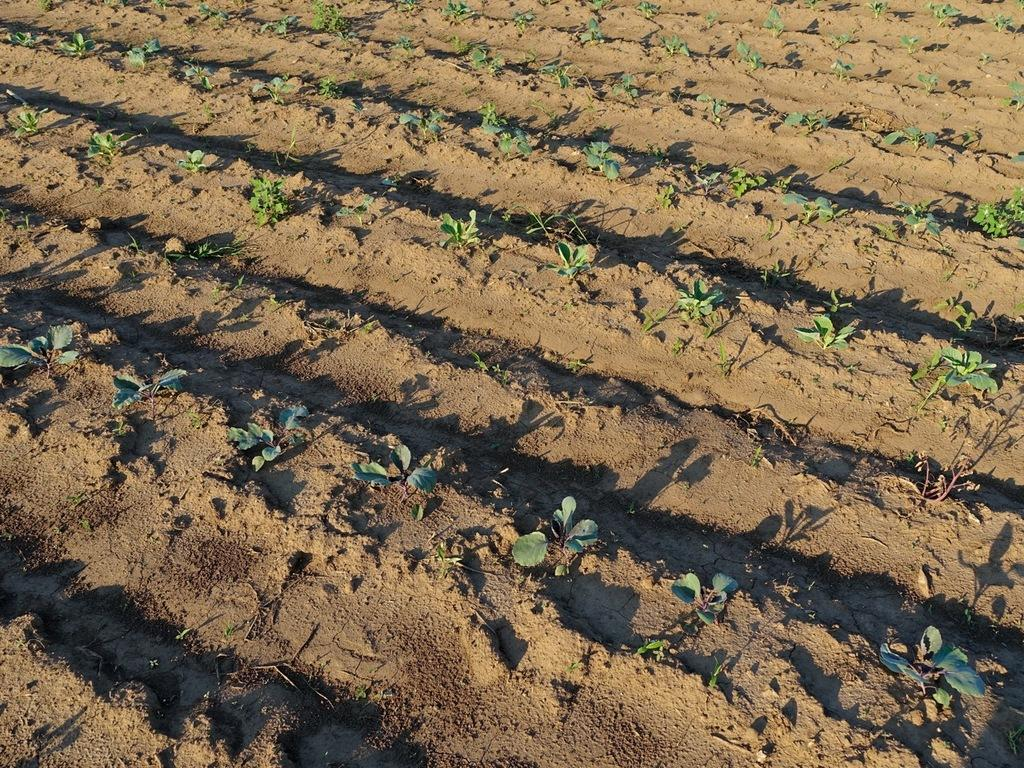What type of plants can be seen in the image? There are small plants in the image. Where are the plants located? The plants are in a field. How many mice are playing with the ship in the image? There is no ship or mice present in the image; it features small plants in a field. 